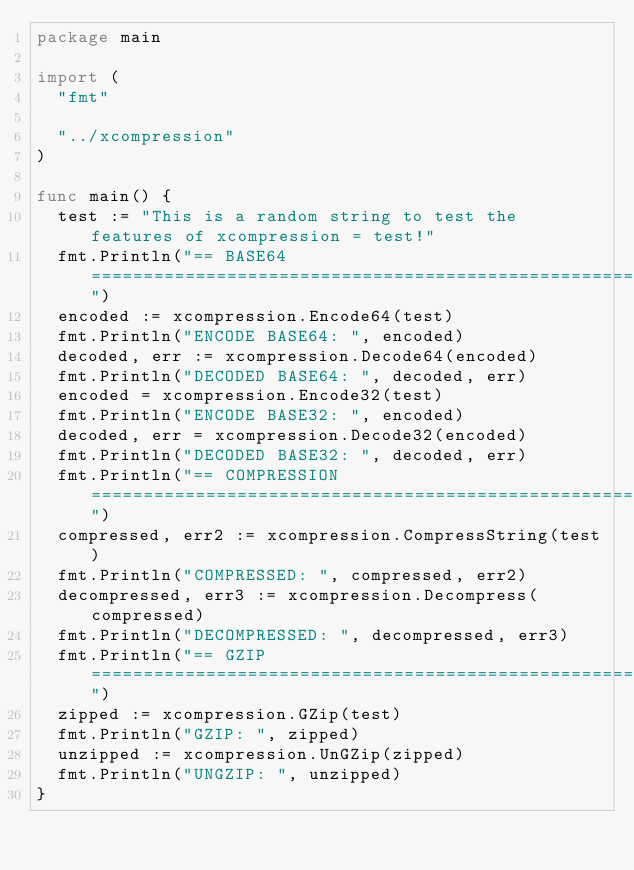Convert code to text. <code><loc_0><loc_0><loc_500><loc_500><_Go_>package main

import (
	"fmt"

	"../xcompression"
)

func main() {
	test := "This is a random string to test the features of xcompression = test!"
	fmt.Println("== BASE64 =================================================================")
	encoded := xcompression.Encode64(test)
	fmt.Println("ENCODE BASE64: ", encoded)
	decoded, err := xcompression.Decode64(encoded)
	fmt.Println("DECODED BASE64: ", decoded, err)
	encoded = xcompression.Encode32(test)
	fmt.Println("ENCODE BASE32: ", encoded)
	decoded, err = xcompression.Decode32(encoded)
	fmt.Println("DECODED BASE32: ", decoded, err)
	fmt.Println("== COMPRESSION ============================================================")
	compressed, err2 := xcompression.CompressString(test)
	fmt.Println("COMPRESSED: ", compressed, err2)
	decompressed, err3 := xcompression.Decompress(compressed)
	fmt.Println("DECOMPRESSED: ", decompressed, err3)
	fmt.Println("== GZIP ===================================================================")
	zipped := xcompression.GZip(test)
	fmt.Println("GZIP: ", zipped)
	unzipped := xcompression.UnGZip(zipped)
	fmt.Println("UNGZIP: ", unzipped)
}
</code> 